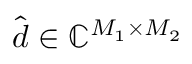Convert formula to latex. <formula><loc_0><loc_0><loc_500><loc_500>\hat { d } \in \mathbb { C } ^ { M _ { 1 } \times M _ { 2 } }</formula> 